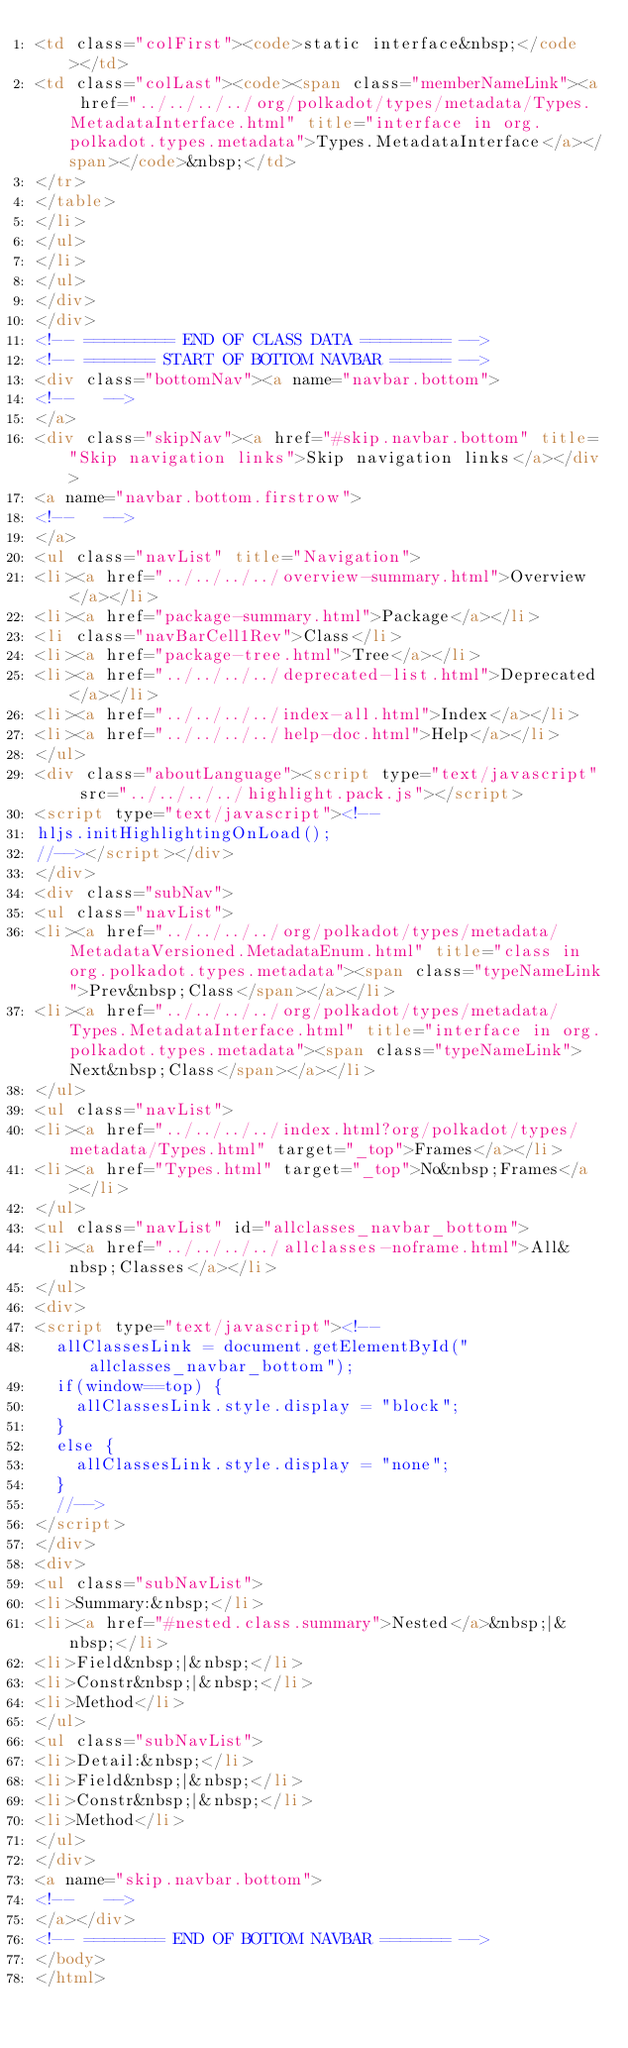<code> <loc_0><loc_0><loc_500><loc_500><_HTML_><td class="colFirst"><code>static interface&nbsp;</code></td>
<td class="colLast"><code><span class="memberNameLink"><a href="../../../../org/polkadot/types/metadata/Types.MetadataInterface.html" title="interface in org.polkadot.types.metadata">Types.MetadataInterface</a></span></code>&nbsp;</td>
</tr>
</table>
</li>
</ul>
</li>
</ul>
</div>
</div>
<!-- ========= END OF CLASS DATA ========= -->
<!-- ======= START OF BOTTOM NAVBAR ====== -->
<div class="bottomNav"><a name="navbar.bottom">
<!--   -->
</a>
<div class="skipNav"><a href="#skip.navbar.bottom" title="Skip navigation links">Skip navigation links</a></div>
<a name="navbar.bottom.firstrow">
<!--   -->
</a>
<ul class="navList" title="Navigation">
<li><a href="../../../../overview-summary.html">Overview</a></li>
<li><a href="package-summary.html">Package</a></li>
<li class="navBarCell1Rev">Class</li>
<li><a href="package-tree.html">Tree</a></li>
<li><a href="../../../../deprecated-list.html">Deprecated</a></li>
<li><a href="../../../../index-all.html">Index</a></li>
<li><a href="../../../../help-doc.html">Help</a></li>
</ul>
<div class="aboutLanguage"><script type="text/javascript" src="../../../../highlight.pack.js"></script>
<script type="text/javascript"><!--
hljs.initHighlightingOnLoad();
//--></script></div>
</div>
<div class="subNav">
<ul class="navList">
<li><a href="../../../../org/polkadot/types/metadata/MetadataVersioned.MetadataEnum.html" title="class in org.polkadot.types.metadata"><span class="typeNameLink">Prev&nbsp;Class</span></a></li>
<li><a href="../../../../org/polkadot/types/metadata/Types.MetadataInterface.html" title="interface in org.polkadot.types.metadata"><span class="typeNameLink">Next&nbsp;Class</span></a></li>
</ul>
<ul class="navList">
<li><a href="../../../../index.html?org/polkadot/types/metadata/Types.html" target="_top">Frames</a></li>
<li><a href="Types.html" target="_top">No&nbsp;Frames</a></li>
</ul>
<ul class="navList" id="allclasses_navbar_bottom">
<li><a href="../../../../allclasses-noframe.html">All&nbsp;Classes</a></li>
</ul>
<div>
<script type="text/javascript"><!--
  allClassesLink = document.getElementById("allclasses_navbar_bottom");
  if(window==top) {
    allClassesLink.style.display = "block";
  }
  else {
    allClassesLink.style.display = "none";
  }
  //-->
</script>
</div>
<div>
<ul class="subNavList">
<li>Summary:&nbsp;</li>
<li><a href="#nested.class.summary">Nested</a>&nbsp;|&nbsp;</li>
<li>Field&nbsp;|&nbsp;</li>
<li>Constr&nbsp;|&nbsp;</li>
<li>Method</li>
</ul>
<ul class="subNavList">
<li>Detail:&nbsp;</li>
<li>Field&nbsp;|&nbsp;</li>
<li>Constr&nbsp;|&nbsp;</li>
<li>Method</li>
</ul>
</div>
<a name="skip.navbar.bottom">
<!--   -->
</a></div>
<!-- ======== END OF BOTTOM NAVBAR ======= -->
</body>
</html>
</code> 